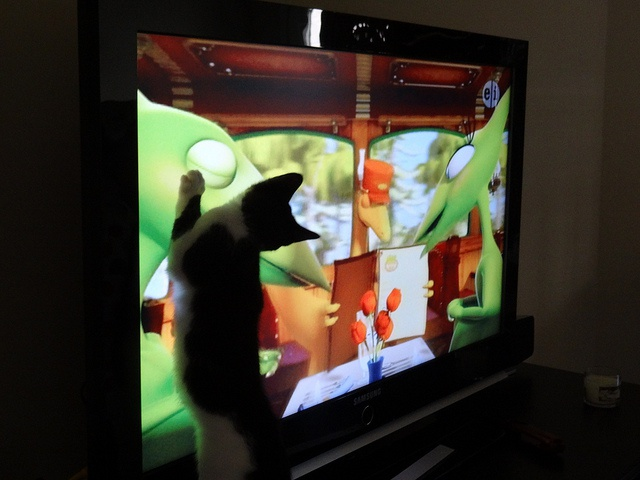Describe the objects in this image and their specific colors. I can see tv in black, maroon, lightgray, and olive tones and cat in black, darkgreen, and gray tones in this image. 